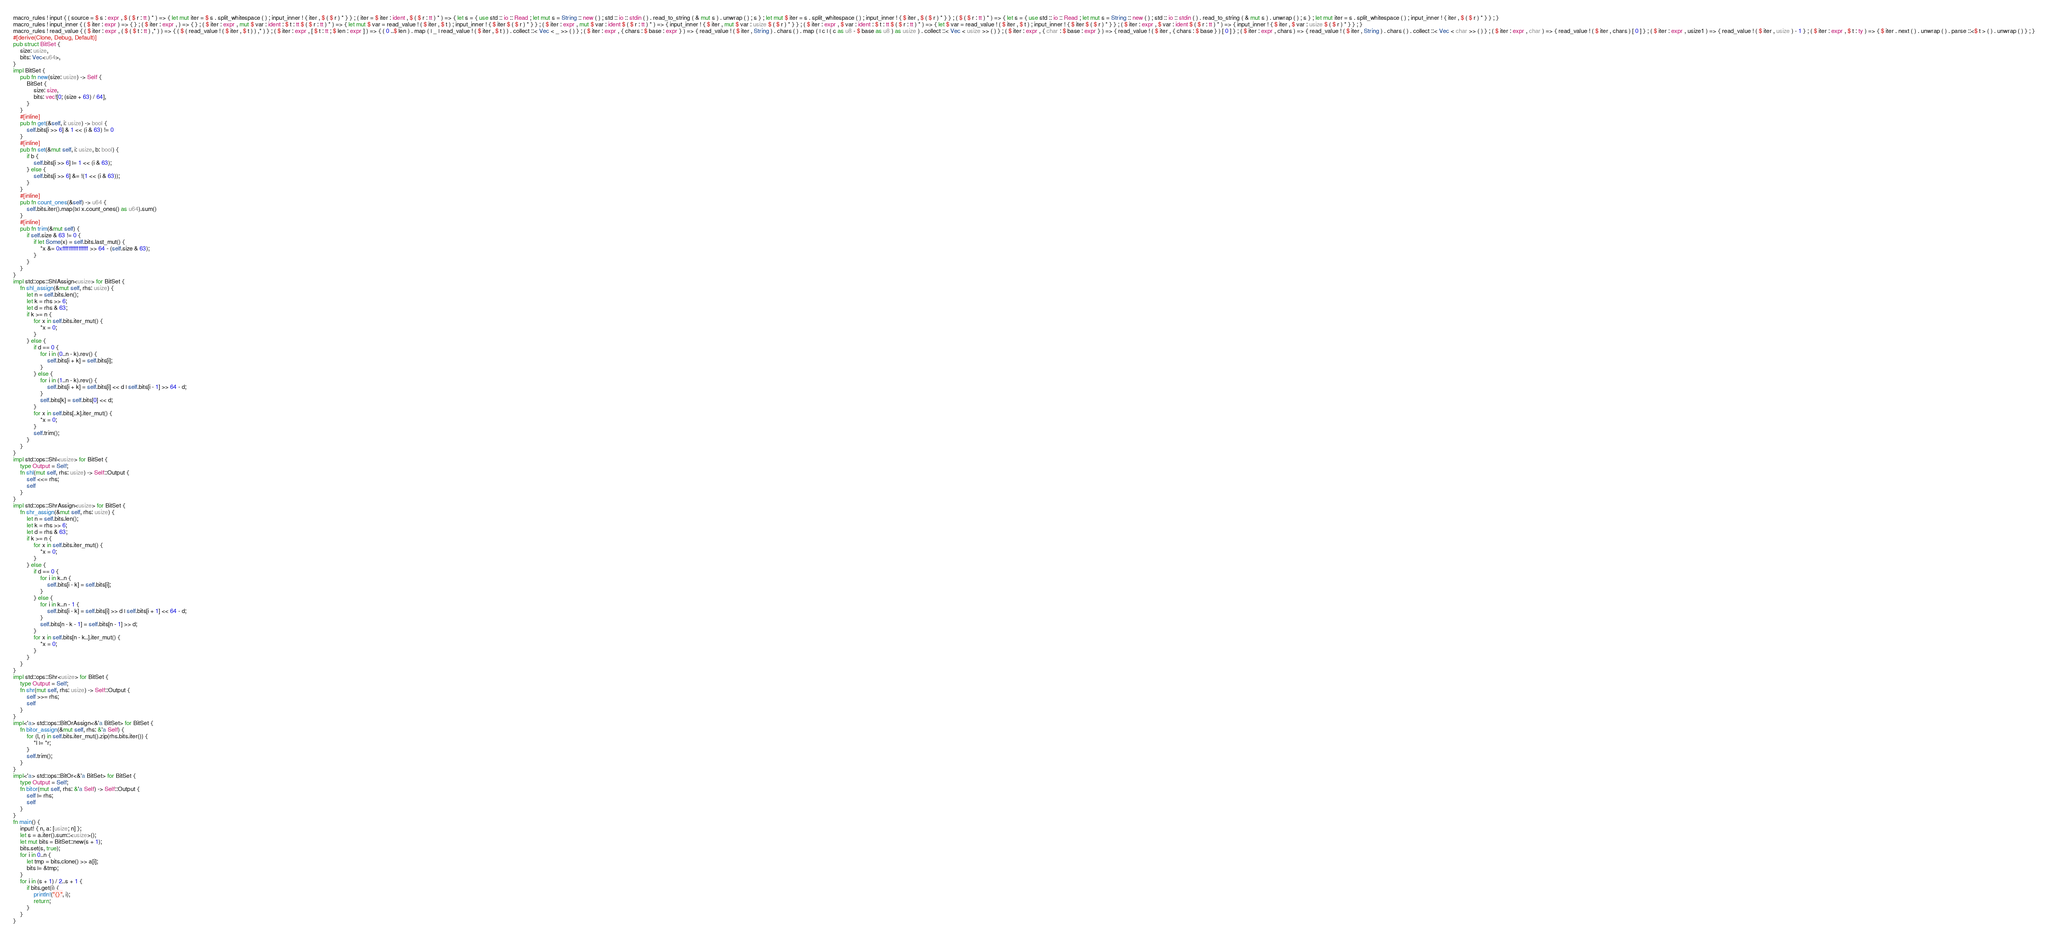Convert code to text. <code><loc_0><loc_0><loc_500><loc_500><_Rust_>macro_rules ! input { ( source = $ s : expr , $ ( $ r : tt ) * ) => { let mut iter = $ s . split_whitespace ( ) ; input_inner ! { iter , $ ( $ r ) * } } ; ( iter = $ iter : ident , $ ( $ r : tt ) * ) => { let s = { use std :: io :: Read ; let mut s = String :: new ( ) ; std :: io :: stdin ( ) . read_to_string ( & mut s ) . unwrap ( ) ; s } ; let mut $ iter = s . split_whitespace ( ) ; input_inner ! { $ iter , $ ( $ r ) * } } ; ( $ ( $ r : tt ) * ) => { let s = { use std :: io :: Read ; let mut s = String :: new ( ) ; std :: io :: stdin ( ) . read_to_string ( & mut s ) . unwrap ( ) ; s } ; let mut iter = s . split_whitespace ( ) ; input_inner ! { iter , $ ( $ r ) * } } ; }
macro_rules ! input_inner { ( $ iter : expr ) => { } ; ( $ iter : expr , ) => { } ; ( $ iter : expr , mut $ var : ident : $ t : tt $ ( $ r : tt ) * ) => { let mut $ var = read_value ! ( $ iter , $ t ) ; input_inner ! { $ iter $ ( $ r ) * } } ; ( $ iter : expr , mut $ var : ident $ ( $ r : tt ) * ) => { input_inner ! { $ iter , mut $ var : usize $ ( $ r ) * } } ; ( $ iter : expr , $ var : ident : $ t : tt $ ( $ r : tt ) * ) => { let $ var = read_value ! ( $ iter , $ t ) ; input_inner ! { $ iter $ ( $ r ) * } } ; ( $ iter : expr , $ var : ident $ ( $ r : tt ) * ) => { input_inner ! { $ iter , $ var : usize $ ( $ r ) * } } ; }
macro_rules ! read_value { ( $ iter : expr , ( $ ( $ t : tt ) ,* ) ) => { ( $ ( read_value ! ( $ iter , $ t ) ) ,* ) } ; ( $ iter : expr , [ $ t : tt ; $ len : expr ] ) => { ( 0 ..$ len ) . map ( | _ | read_value ! ( $ iter , $ t ) ) . collect ::< Vec < _ >> ( ) } ; ( $ iter : expr , { chars : $ base : expr } ) => { read_value ! ( $ iter , String ) . chars ( ) . map ( | c | ( c as u8 - $ base as u8 ) as usize ) . collect ::< Vec < usize >> ( ) } ; ( $ iter : expr , { char : $ base : expr } ) => { read_value ! ( $ iter , { chars : $ base } ) [ 0 ] } ; ( $ iter : expr , chars ) => { read_value ! ( $ iter , String ) . chars ( ) . collect ::< Vec < char >> ( ) } ; ( $ iter : expr , char ) => { read_value ! ( $ iter , chars ) [ 0 ] } ; ( $ iter : expr , usize1 ) => { read_value ! ( $ iter , usize ) - 1 } ; ( $ iter : expr , $ t : ty ) => { $ iter . next ( ) . unwrap ( ) . parse ::<$ t > ( ) . unwrap ( ) } ; }
#[derive(Clone, Debug, Default)]
pub struct BitSet {
    size: usize,
    bits: Vec<u64>,
}
impl BitSet {
    pub fn new(size: usize) -> Self {
        BitSet {
            size: size,
            bits: vec![0; (size + 63) / 64],
        }
    }
    #[inline]
    pub fn get(&self, i: usize) -> bool {
        self.bits[i >> 6] & 1 << (i & 63) != 0
    }
    #[inline]
    pub fn set(&mut self, i: usize, b: bool) {
        if b {
            self.bits[i >> 6] |= 1 << (i & 63);
        } else {
            self.bits[i >> 6] &= !(1 << (i & 63));
        }
    }
    #[inline]
    pub fn count_ones(&self) -> u64 {
        self.bits.iter().map(|x| x.count_ones() as u64).sum()
    }
    #[inline]
    pub fn trim(&mut self) {
        if self.size & 63 != 0 {
            if let Some(x) = self.bits.last_mut() {
                *x &= 0xffffffffffffffff >> 64 - (self.size & 63);
            }
        }
    }
}
impl std::ops::ShlAssign<usize> for BitSet {
    fn shl_assign(&mut self, rhs: usize) {
        let n = self.bits.len();
        let k = rhs >> 6;
        let d = rhs & 63;
        if k >= n {
            for x in self.bits.iter_mut() {
                *x = 0;
            }
        } else {
            if d == 0 {
                for i in (0..n - k).rev() {
                    self.bits[i + k] = self.bits[i];
                }
            } else {
                for i in (1..n - k).rev() {
                    self.bits[i + k] = self.bits[i] << d | self.bits[i - 1] >> 64 - d;
                }
                self.bits[k] = self.bits[0] << d;
            }
            for x in self.bits[..k].iter_mut() {
                *x = 0;
            }
            self.trim();
        }
    }
}
impl std::ops::Shl<usize> for BitSet {
    type Output = Self;
    fn shl(mut self, rhs: usize) -> Self::Output {
        self <<= rhs;
        self
    }
}
impl std::ops::ShrAssign<usize> for BitSet {
    fn shr_assign(&mut self, rhs: usize) {
        let n = self.bits.len();
        let k = rhs >> 6;
        let d = rhs & 63;
        if k >= n {
            for x in self.bits.iter_mut() {
                *x = 0;
            }
        } else {
            if d == 0 {
                for i in k..n {
                    self.bits[i - k] = self.bits[i];
                }
            } else {
                for i in k..n - 1 {
                    self.bits[i - k] = self.bits[i] >> d | self.bits[i + 1] << 64 - d;
                }
                self.bits[n - k - 1] = self.bits[n - 1] >> d;
            }
            for x in self.bits[n - k..].iter_mut() {
                *x = 0;
            }
        }
    }
}
impl std::ops::Shr<usize> for BitSet {
    type Output = Self;
    fn shr(mut self, rhs: usize) -> Self::Output {
        self >>= rhs;
        self
    }
}
impl<'a> std::ops::BitOrAssign<&'a BitSet> for BitSet {
    fn bitor_assign(&mut self, rhs: &'a Self) {
        for (l, r) in self.bits.iter_mut().zip(rhs.bits.iter()) {
            *l |= *r;
        }
        self.trim();
    }
}
impl<'a> std::ops::BitOr<&'a BitSet> for BitSet {
    type Output = Self;
    fn bitor(mut self, rhs: &'a Self) -> Self::Output {
        self |= rhs;
        self
    }
}
fn main() {
    input! { n, a: [usize; n] };
    let s = a.iter().sum::<usize>();
    let mut bits = BitSet::new(s + 1);
    bits.set(s, true);
    for i in 0..n {
        let tmp = bits.clone() >> a[i];
        bits |= &tmp;
    }
    for i in (s + 1) / 2..s + 1 {
        if bits.get(i) {
            println!("{}", i);
            return;
        }
    }
}
</code> 